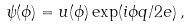<formula> <loc_0><loc_0><loc_500><loc_500>\psi ( \phi ) = u ( \phi ) \exp ( i \phi q / 2 e ) \, ,</formula> 